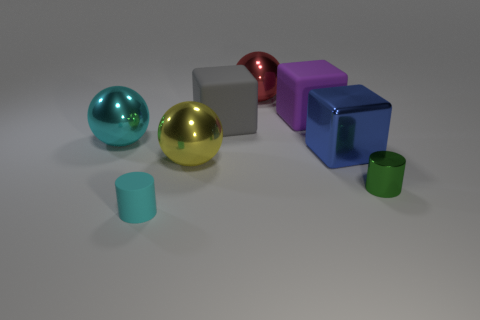Subtract 1 balls. How many balls are left? 2 Add 1 cyan shiny spheres. How many objects exist? 9 Subtract all blocks. How many objects are left? 5 Add 4 large yellow things. How many large yellow things exist? 5 Subtract 0 brown cubes. How many objects are left? 8 Subtract all cyan balls. Subtract all metal things. How many objects are left? 2 Add 3 metallic objects. How many metallic objects are left? 8 